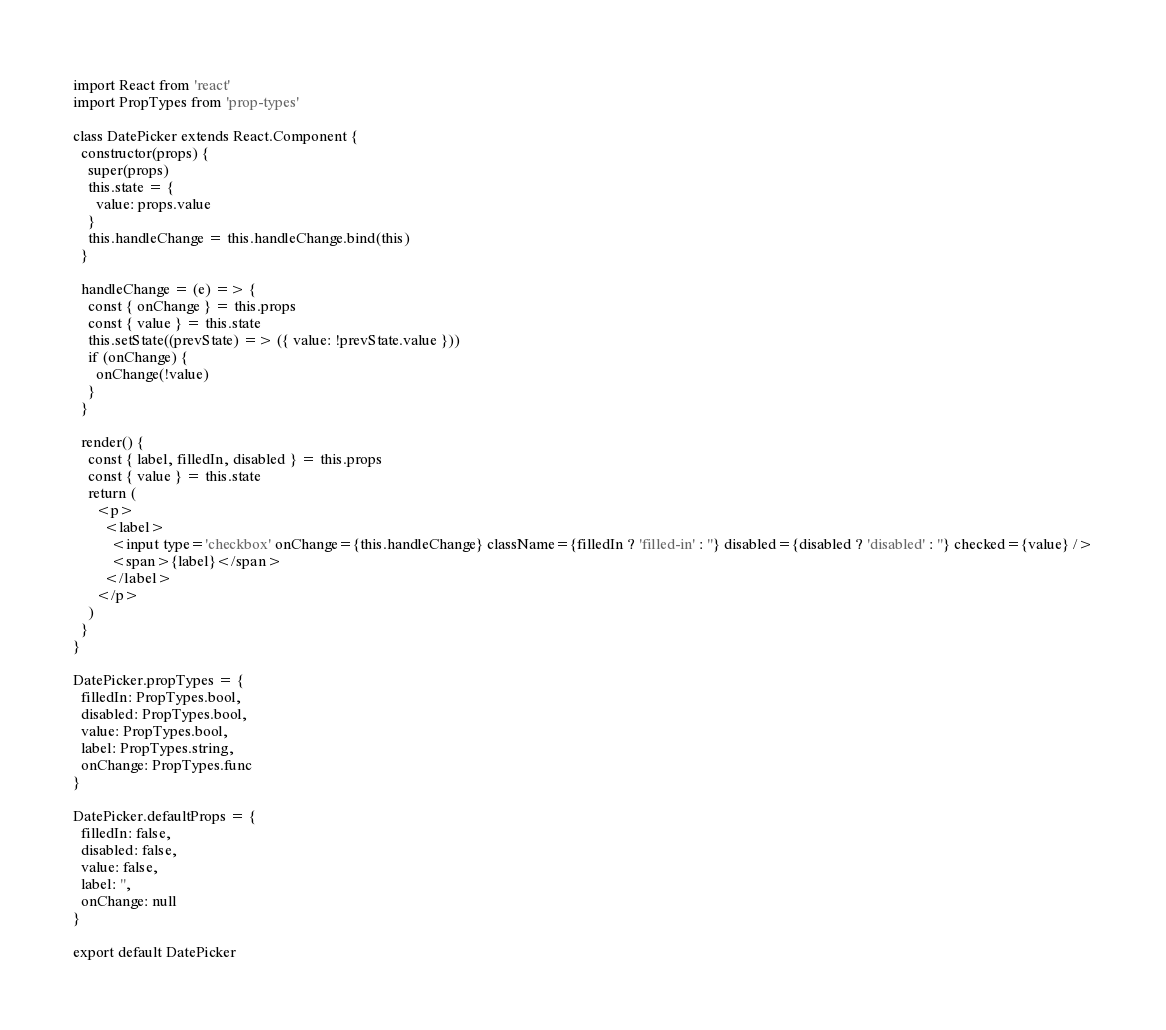Convert code to text. <code><loc_0><loc_0><loc_500><loc_500><_JavaScript_>import React from 'react'
import PropTypes from 'prop-types'

class DatePicker extends React.Component {
  constructor(props) {
    super(props)
    this.state = {
      value: props.value
    }
    this.handleChange = this.handleChange.bind(this)
  }

  handleChange = (e) => {
    const { onChange } = this.props
    const { value } = this.state
    this.setState((prevState) => ({ value: !prevState.value }))
    if (onChange) {
      onChange(!value)
    }
  }

  render() {
    const { label, filledIn, disabled } = this.props
    const { value } = this.state
    return (
      <p>
        <label>
          <input type='checkbox' onChange={this.handleChange} className={filledIn ? 'filled-in' : ''} disabled={disabled ? 'disabled' : ''} checked={value} />
          <span>{label}</span>
        </label>
      </p>
    )
  }
}

DatePicker.propTypes = {
  filledIn: PropTypes.bool,
  disabled: PropTypes.bool,
  value: PropTypes.bool,
  label: PropTypes.string,
  onChange: PropTypes.func
}

DatePicker.defaultProps = {
  filledIn: false,
  disabled: false,
  value: false,
  label: '',
  onChange: null
}

export default DatePicker
</code> 